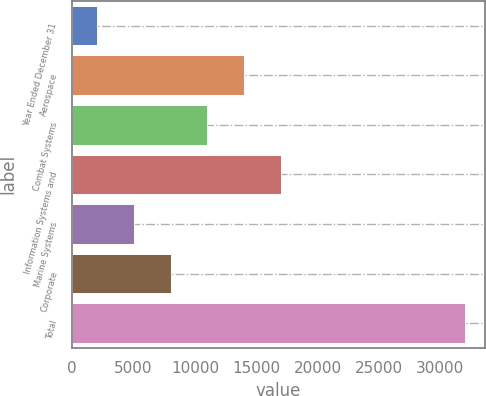Convert chart to OTSL. <chart><loc_0><loc_0><loc_500><loc_500><bar_chart><fcel>Year Ended December 31<fcel>Aerospace<fcel>Combat Systems<fcel>Information Systems and<fcel>Marine Systems<fcel>Corporate<fcel>Total<nl><fcel>2015<fcel>14007.8<fcel>11009.6<fcel>17006<fcel>5013.2<fcel>8011.4<fcel>31997<nl></chart> 